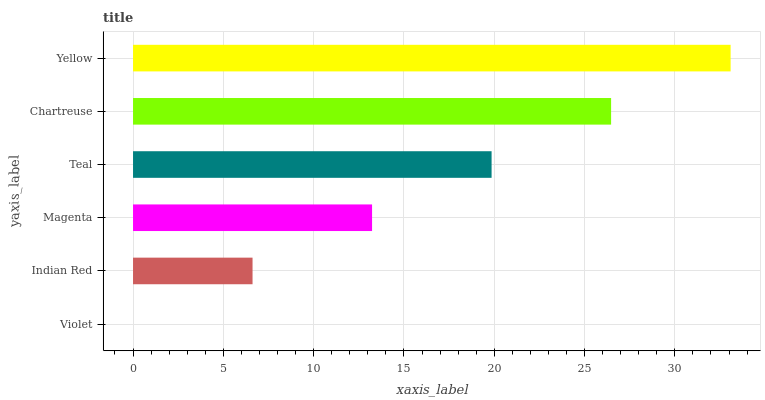Is Violet the minimum?
Answer yes or no. Yes. Is Yellow the maximum?
Answer yes or no. Yes. Is Indian Red the minimum?
Answer yes or no. No. Is Indian Red the maximum?
Answer yes or no. No. Is Indian Red greater than Violet?
Answer yes or no. Yes. Is Violet less than Indian Red?
Answer yes or no. Yes. Is Violet greater than Indian Red?
Answer yes or no. No. Is Indian Red less than Violet?
Answer yes or no. No. Is Teal the high median?
Answer yes or no. Yes. Is Magenta the low median?
Answer yes or no. Yes. Is Magenta the high median?
Answer yes or no. No. Is Teal the low median?
Answer yes or no. No. 